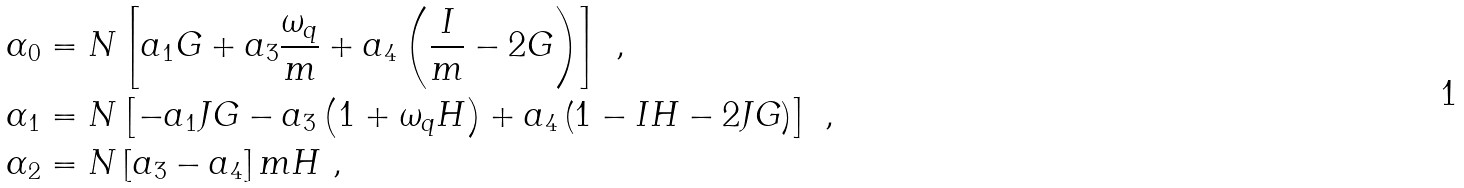<formula> <loc_0><loc_0><loc_500><loc_500>\alpha _ { 0 } & = N \left [ a _ { 1 } G + a _ { 3 } \frac { \omega _ { q } } { m } + a _ { 4 } \left ( \frac { I } { m } - 2 G \right ) \right ] \ , \\ \alpha _ { 1 } & = N \left [ - a _ { 1 } J G - a _ { 3 } \left ( 1 + \omega _ { q } H \right ) + a _ { 4 } \left ( 1 - I H - 2 J G \right ) \right ] \ , \\ \alpha _ { 2 } & = N \left [ a _ { 3 } - a _ { 4 } \right ] m H \ ,</formula> 